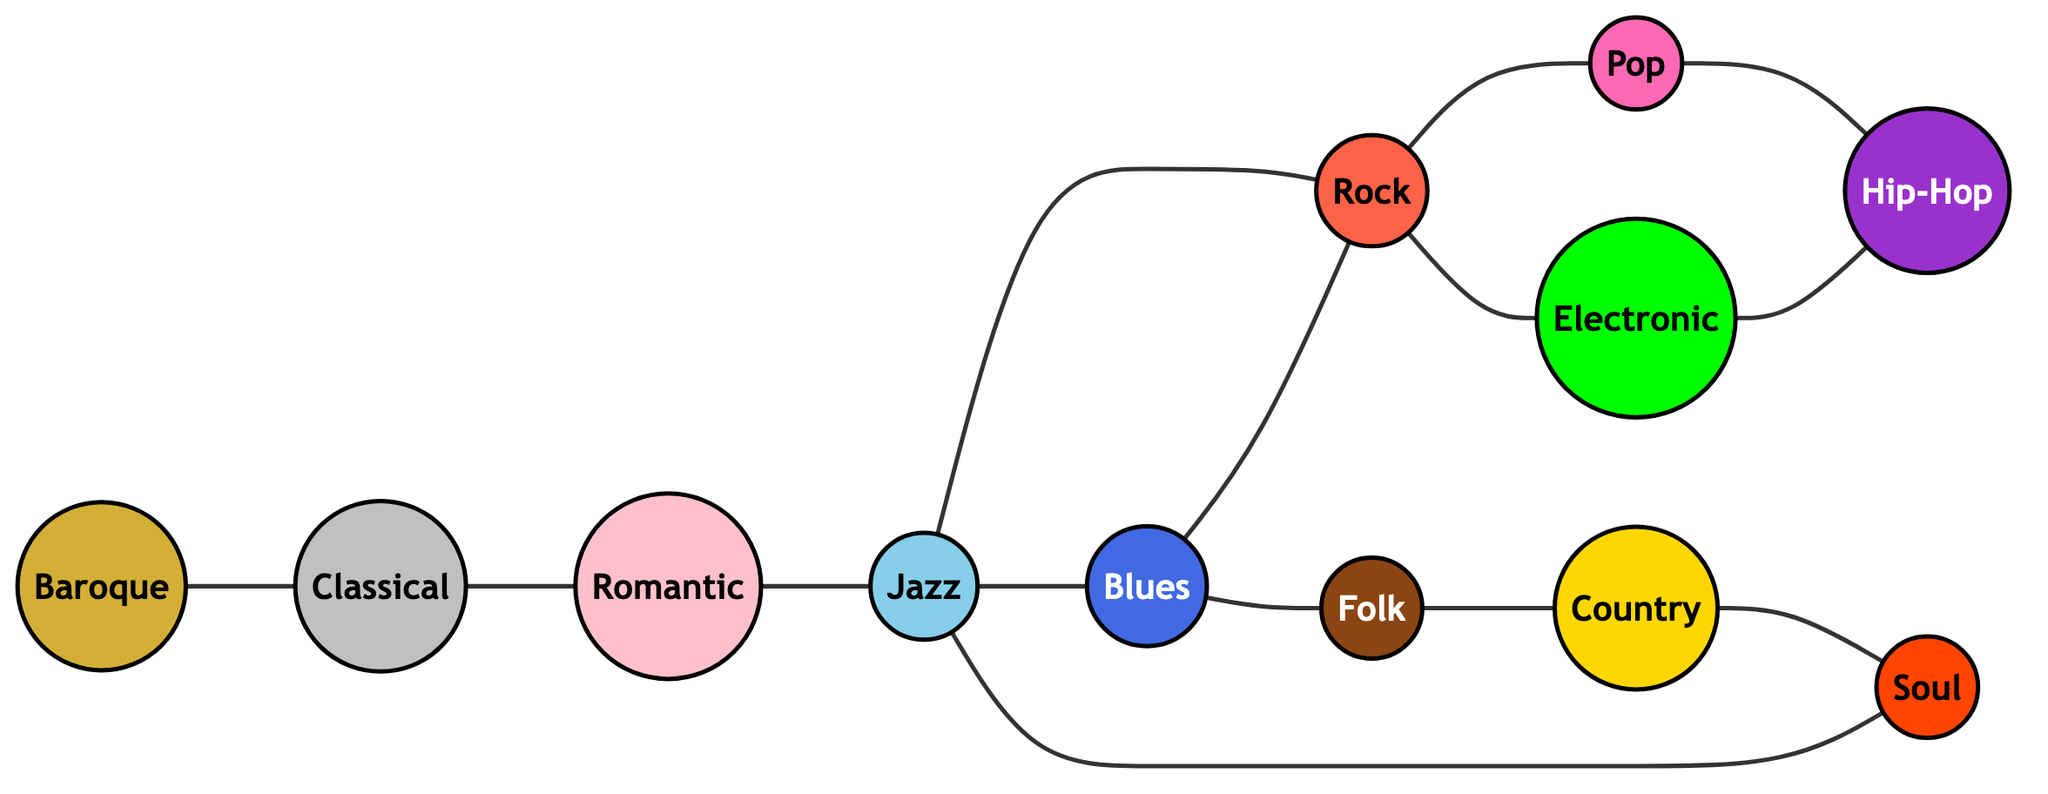What's the total number of music genres represented in the diagram? The diagram lists 12 distinct music genres, each represented by a node without repetition. By counting the nodes, we find a total of 12 genres.
Answer: 12 Which genres are directly connected to Jazz? In the diagram, Jazz (node 4) has edges connecting it to Blues (5), Rock (6), and Romantic (3). Therefore, the directly connected genres are Blues, Rock, and Romantic.
Answer: Blues, Rock, Romantic How many edges connect Folk to other genres? Looking at the diagram, Folk (node 10) has edges that connect it to Blues (5) and Country (11). Counting these edges, we find there are 2 connections.
Answer: 2 What is the relationship between Classical and Blues? The diagram shows that there are no direct connections (edges) between Classical (node 2) and Blues (node 5). Therefore, they are not directly related in the network.
Answer: No direct connection Which genre has the maximum number of direct connections? To find the genre with the most connections, we must count the edges for each node. Rock (node 6) has 4 connections (to Jazz, Blues, Pop, and Electronic), which is the highest among all genres.
Answer: Rock Is there a cycle involving Soul? By tracing the connections, we see that Soul (node 12) connects to Country (11), which in turn connects to Folk (10) and then Blues (5) that further connects to Jazz (4). Finally, Jazz connects back to Soul, forming a cycle.
Answer: Yes What are the genres leading to Hip-Hop? The diagram shows that Hip-Hop (node 8) is connected to Pop (7) and Electronic (9). Therefore, the genres that lead to Hip-Hop are Pop and Electronic.
Answer: Pop, Electronic Which genre serves as a historical predecessor to Rock? The diagram illustrates that Rock (node 6) is directly connected to Jazz (4). Therefore, Jazz serves as a predecessor to Rock in the historical progression shown in the network.
Answer: Jazz 